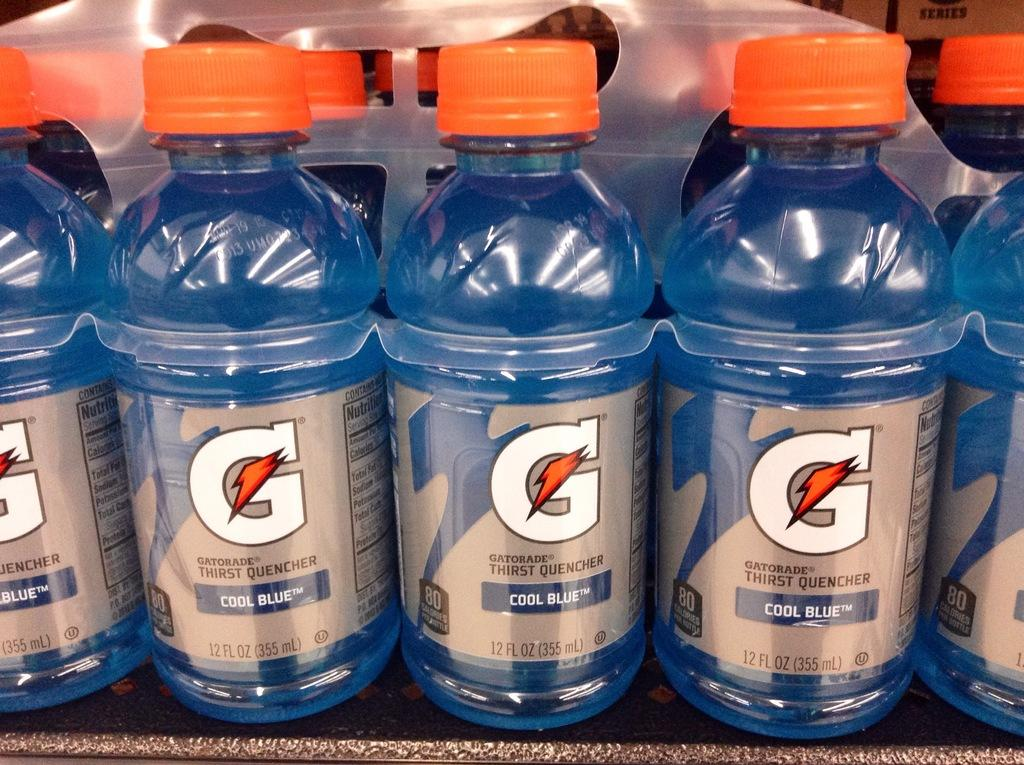<image>
Write a terse but informative summary of the picture. Several bottles of Cool Blue Gatorade are lined up on a store shelf. 